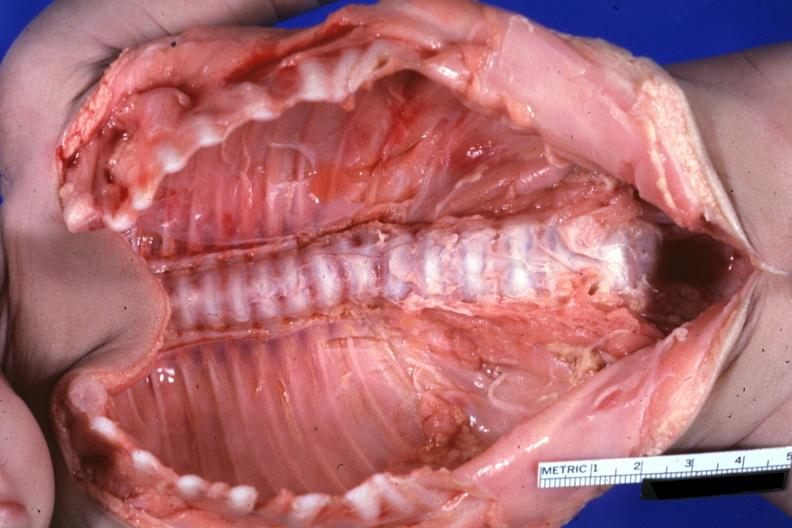do natural color lesion at t12 see protocol?
Answer the question using a single word or phrase. Yes 